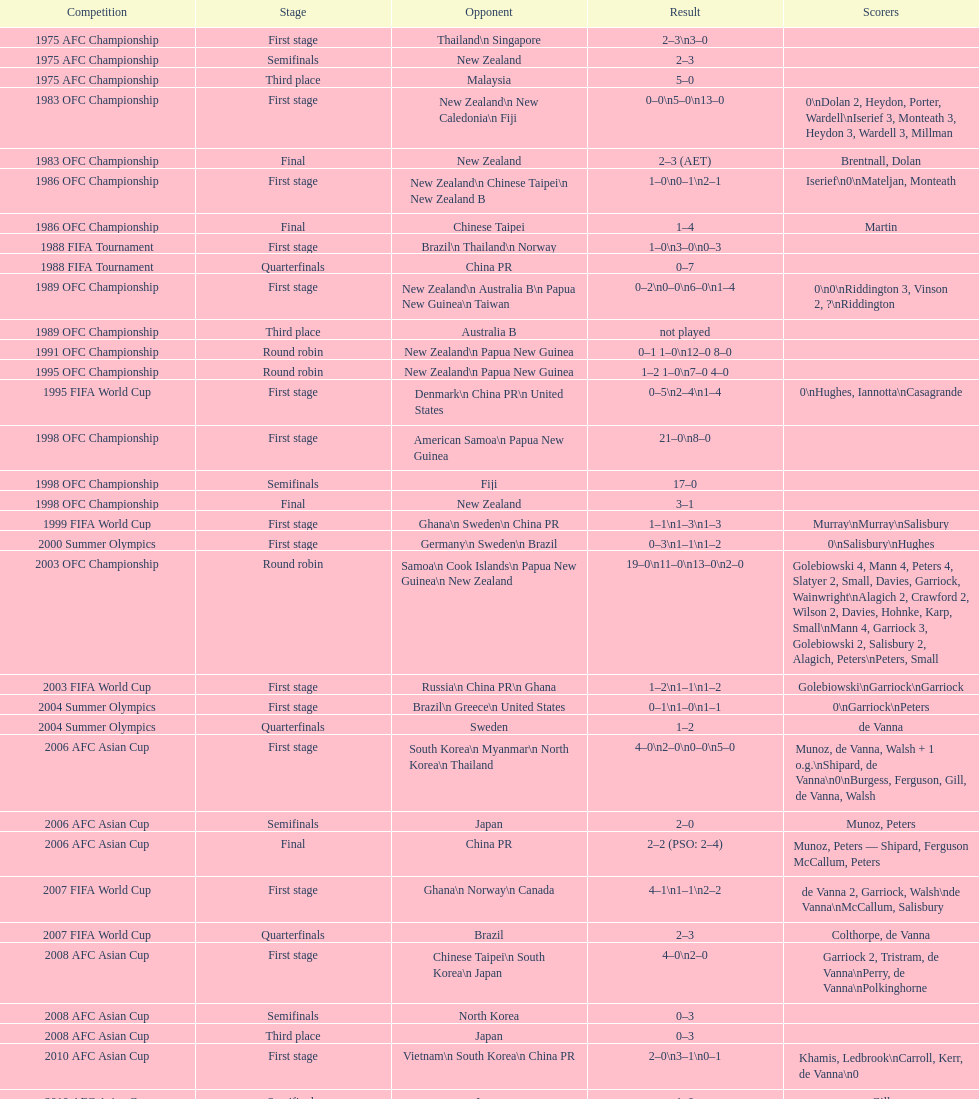What was the number of stages in round robins? 3. 